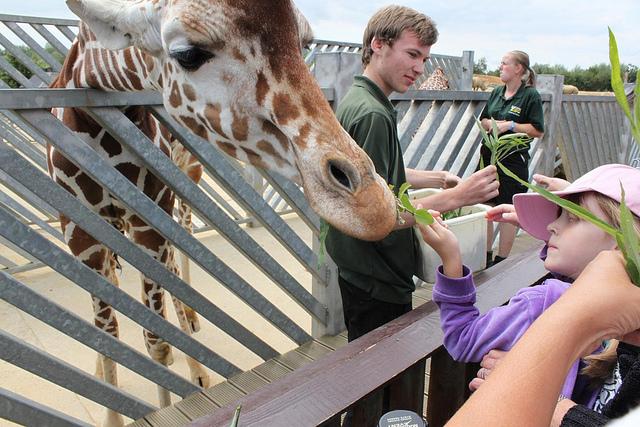Are the animal handlers feeding the animals?
Concise answer only. No. Is this a zoo?
Keep it brief. Yes. Is the zookeeper feeding the people?
Be succinct. No. 